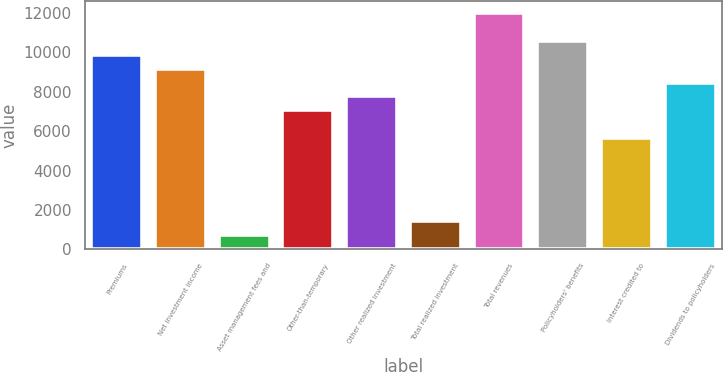<chart> <loc_0><loc_0><loc_500><loc_500><bar_chart><fcel>Premiums<fcel>Net investment income<fcel>Asset management fees and<fcel>Other-than-temporary<fcel>Other realized investment<fcel>Total realized investment<fcel>Total revenues<fcel>Policyholders' benefits<fcel>Interest credited to<fcel>Dividends to policyholders<nl><fcel>9879.8<fcel>9174.6<fcel>712.2<fcel>7059<fcel>7764.2<fcel>1417.4<fcel>11995.4<fcel>10585<fcel>5648.6<fcel>8469.4<nl></chart> 